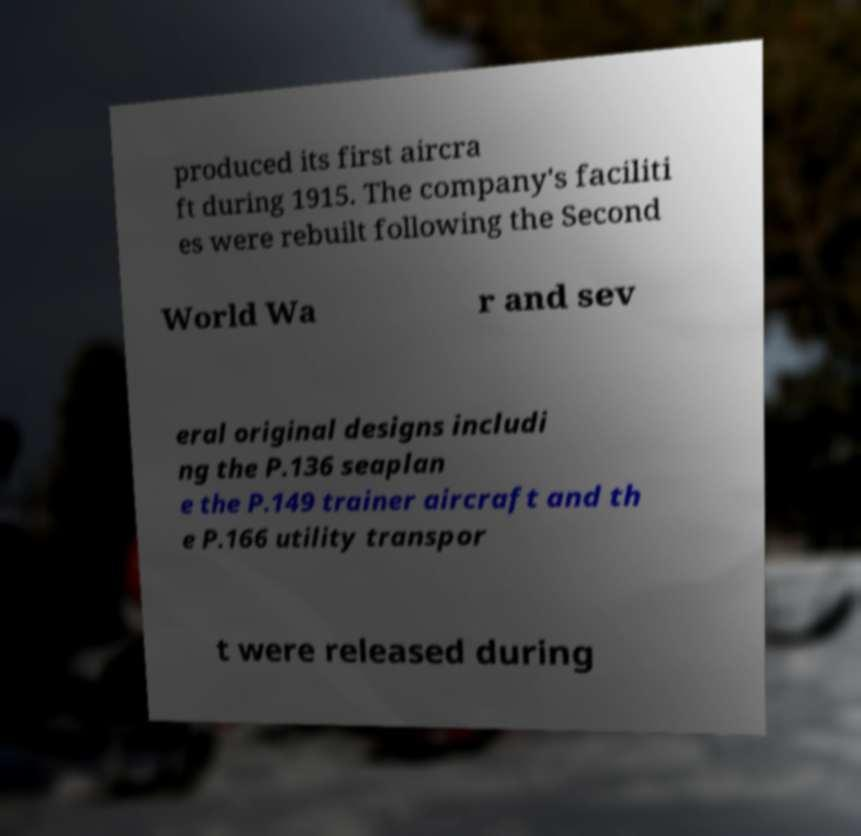I need the written content from this picture converted into text. Can you do that? produced its first aircra ft during 1915. The company's faciliti es were rebuilt following the Second World Wa r and sev eral original designs includi ng the P.136 seaplan e the P.149 trainer aircraft and th e P.166 utility transpor t were released during 